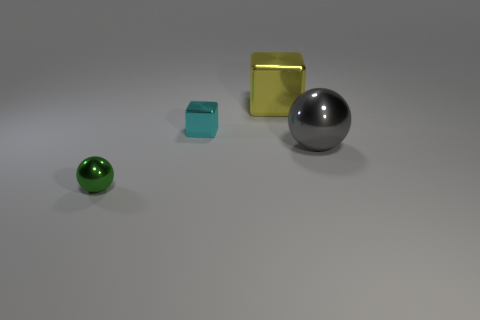There is a big thing behind the gray metallic thing; does it have the same shape as the cyan object?
Ensure brevity in your answer.  Yes. Is the size of the cyan cube the same as the metal ball behind the small green thing?
Offer a terse response. No. How many other objects are there of the same color as the small shiny cube?
Offer a terse response. 0. There is a large yellow block; are there any big yellow metal blocks to the left of it?
Ensure brevity in your answer.  No. How many things are either tiny green cylinders or metal spheres that are on the left side of the gray metallic thing?
Keep it short and to the point. 1. There is a large metallic thing in front of the small metallic cube; are there any small green balls that are on the right side of it?
Make the answer very short. No. What is the shape of the shiny object that is right of the metallic cube that is to the right of the metallic block left of the large yellow block?
Offer a terse response. Sphere. What color is the thing that is right of the cyan metal thing and in front of the big yellow metallic thing?
Make the answer very short. Gray. What shape is the small metallic object that is right of the small sphere?
Ensure brevity in your answer.  Cube. The gray thing that is made of the same material as the small green sphere is what shape?
Ensure brevity in your answer.  Sphere. 